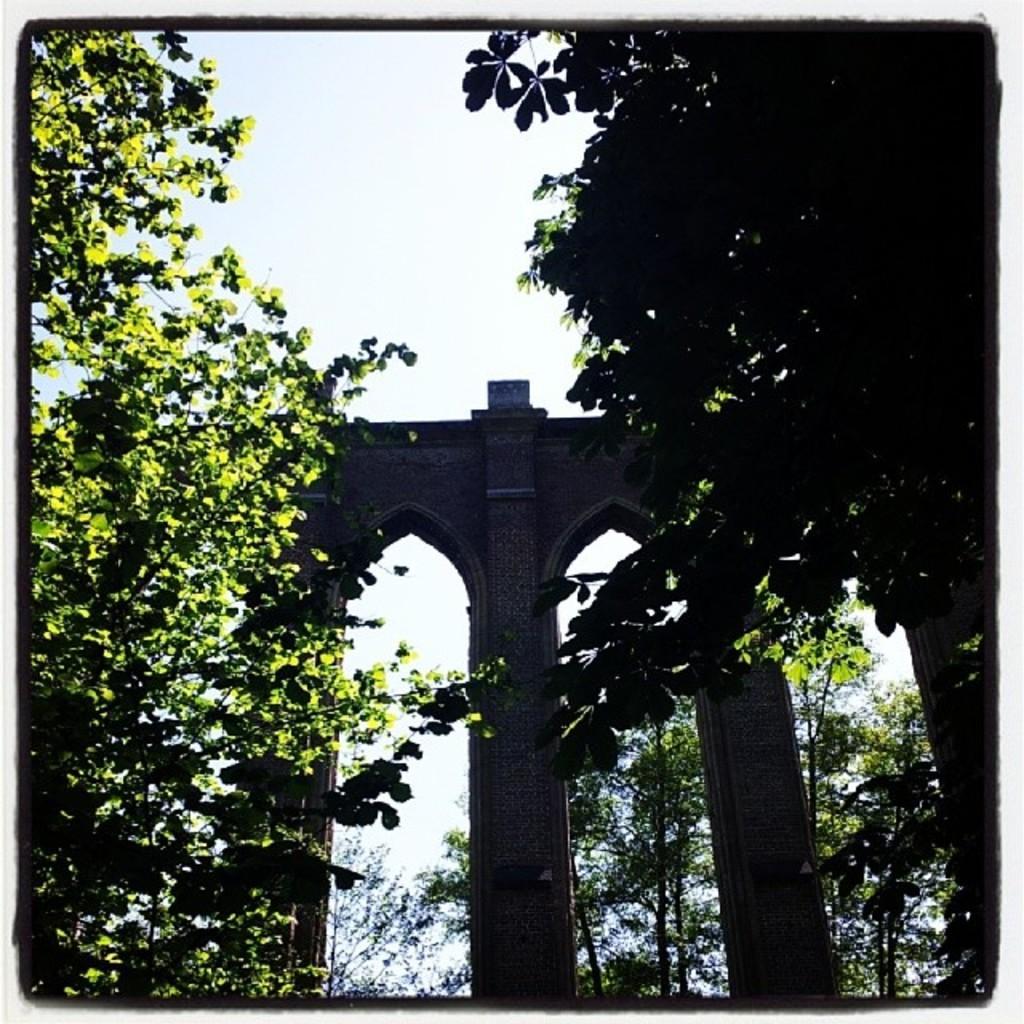Please provide a concise description of this image. In the image we can see there is an arch and there are trees. There is a clear sky. 